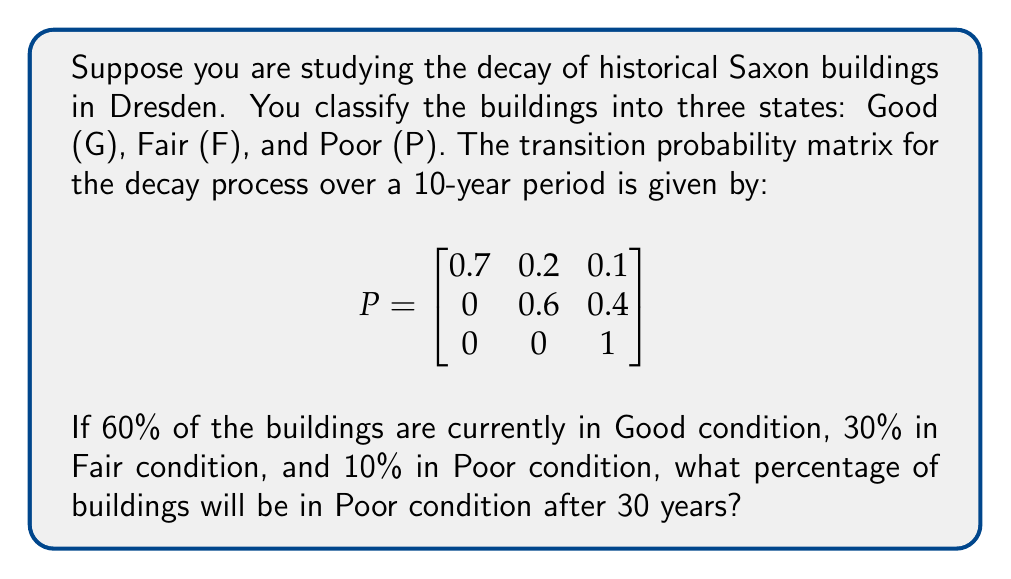Solve this math problem. To solve this problem, we need to use the properties of Markov chains:

1. First, let's define the initial state vector:
   $$\pi_0 = [0.6, 0.3, 0.1]$$

2. We need to find the state after 30 years, which means we need to multiply the initial state by the transition matrix three times (since each transition represents 10 years):
   $$\pi_3 = \pi_0 \cdot P^3$$

3. Let's calculate $P^2$ first:
   $$P^2 = P \cdot P = \begin{bmatrix}
   0.49 & 0.26 & 0.25 \\
   0 & 0.36 & 0.64 \\
   0 & 0 & 1
   \end{bmatrix}$$

4. Now let's calculate $P^3$:
   $$P^3 = P^2 \cdot P = \begin{bmatrix}
   0.343 & 0.238 & 0.419 \\
   0 & 0.216 & 0.784 \\
   0 & 0 & 1
   \end{bmatrix}$$

5. Now we can multiply the initial state by $P^3$:
   $$\pi_3 = [0.6, 0.3, 0.1] \cdot \begin{bmatrix}
   0.343 & 0.238 & 0.419 \\
   0 & 0.216 & 0.784 \\
   0 & 0 & 1
   \end{bmatrix}$$

6. Performing the matrix multiplication:
   $$\pi_3 = [0.2058, 0.2088, 0.5854]$$

7. The last element of this vector represents the proportion of buildings in Poor condition after 30 years.

8. Converting to a percentage: $0.5854 \times 100\% = 58.54\%$
Answer: 58.54% 